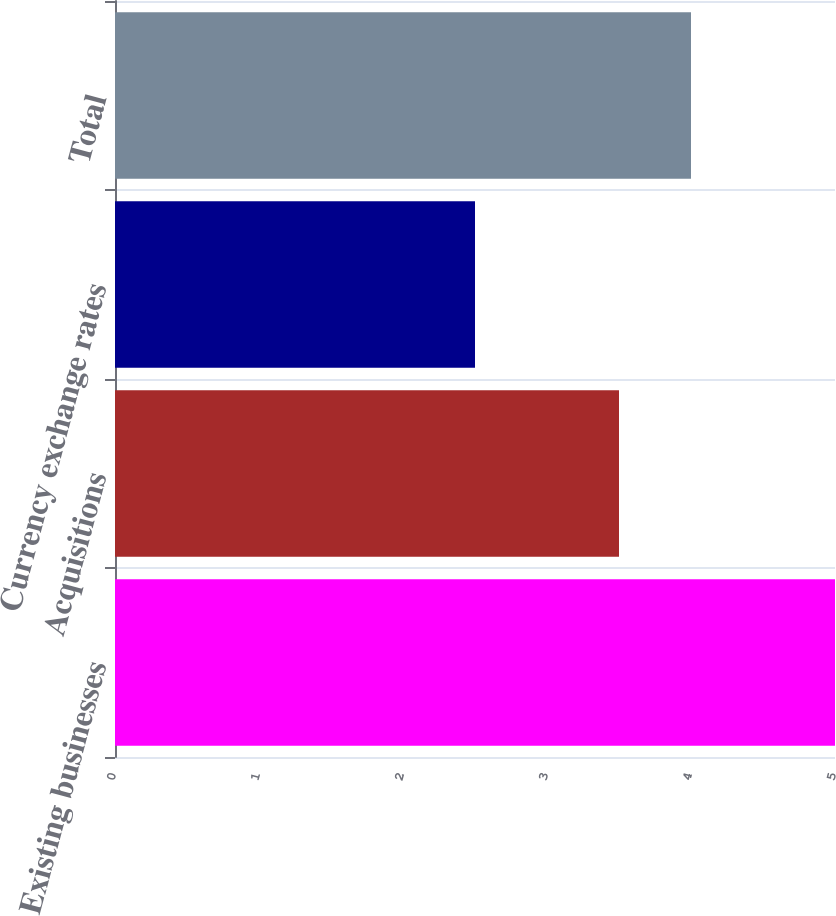Convert chart. <chart><loc_0><loc_0><loc_500><loc_500><bar_chart><fcel>Existing businesses<fcel>Acquisitions<fcel>Currency exchange rates<fcel>Total<nl><fcel>5<fcel>3.5<fcel>2.5<fcel>4<nl></chart> 